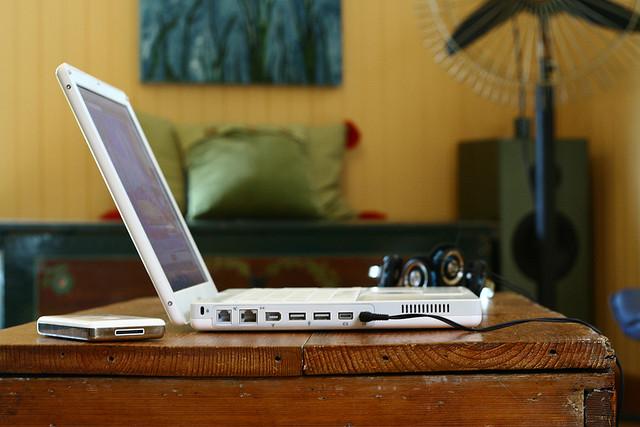What is the desk made of?
Concise answer only. Wood. Are the laptop and desk made of similar materials?
Answer briefly. No. What is standing in the  right hand corner?
Write a very short answer. Fan. 